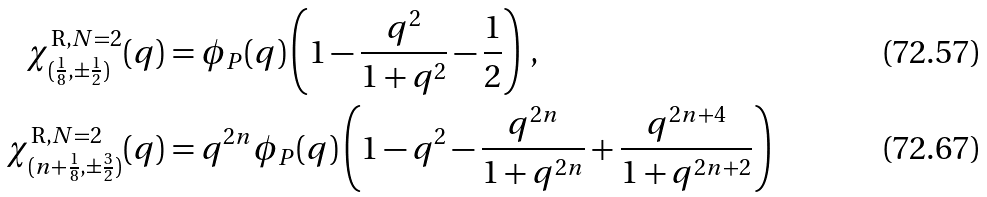<formula> <loc_0><loc_0><loc_500><loc_500>\chi _ { ( \frac { 1 } { 8 } , \pm \frac { 1 } { 2 } ) } ^ { \text {R} , N = 2 } ( q ) & = \phi _ { P } ( q ) \left ( 1 - \frac { q ^ { 2 } } { 1 + q ^ { 2 } } - \frac { 1 } { 2 } \right ) \, , \\ \chi _ { ( n + \frac { 1 } { 8 } , \pm \frac { 3 } { 2 } ) } ^ { \text {R} , N = 2 } ( q ) & = q ^ { 2 n } \phi _ { P } ( q ) \left ( 1 - q ^ { 2 } - \frac { q ^ { 2 n } } { 1 + q ^ { 2 n } } + \frac { q ^ { 2 n + 4 } } { 1 + q ^ { 2 n + 2 } } \right )</formula> 